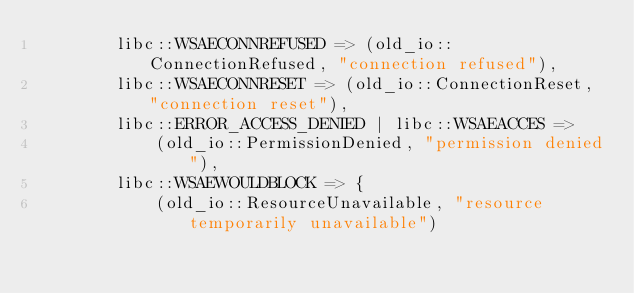<code> <loc_0><loc_0><loc_500><loc_500><_Rust_>        libc::WSAECONNREFUSED => (old_io::ConnectionRefused, "connection refused"),
        libc::WSAECONNRESET => (old_io::ConnectionReset, "connection reset"),
        libc::ERROR_ACCESS_DENIED | libc::WSAEACCES =>
            (old_io::PermissionDenied, "permission denied"),
        libc::WSAEWOULDBLOCK => {
            (old_io::ResourceUnavailable, "resource temporarily unavailable")</code> 